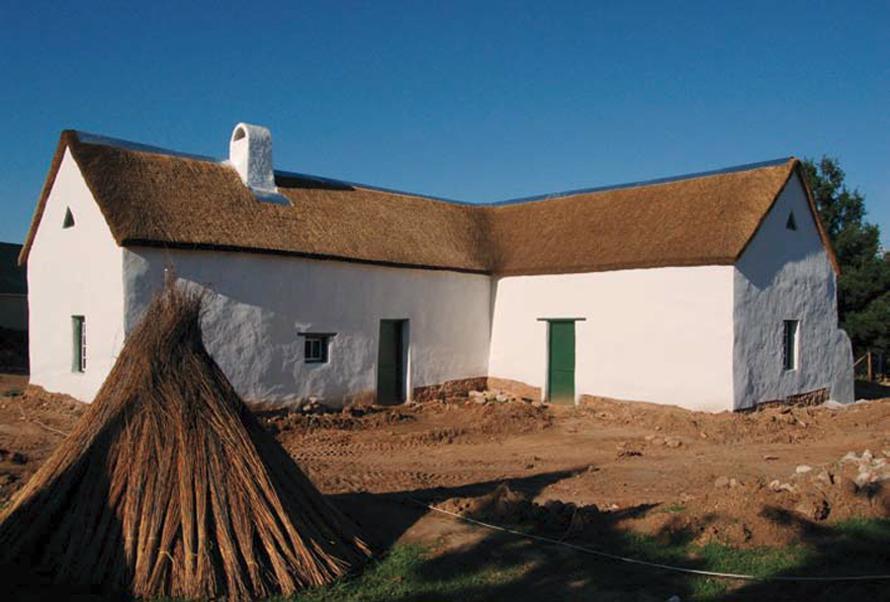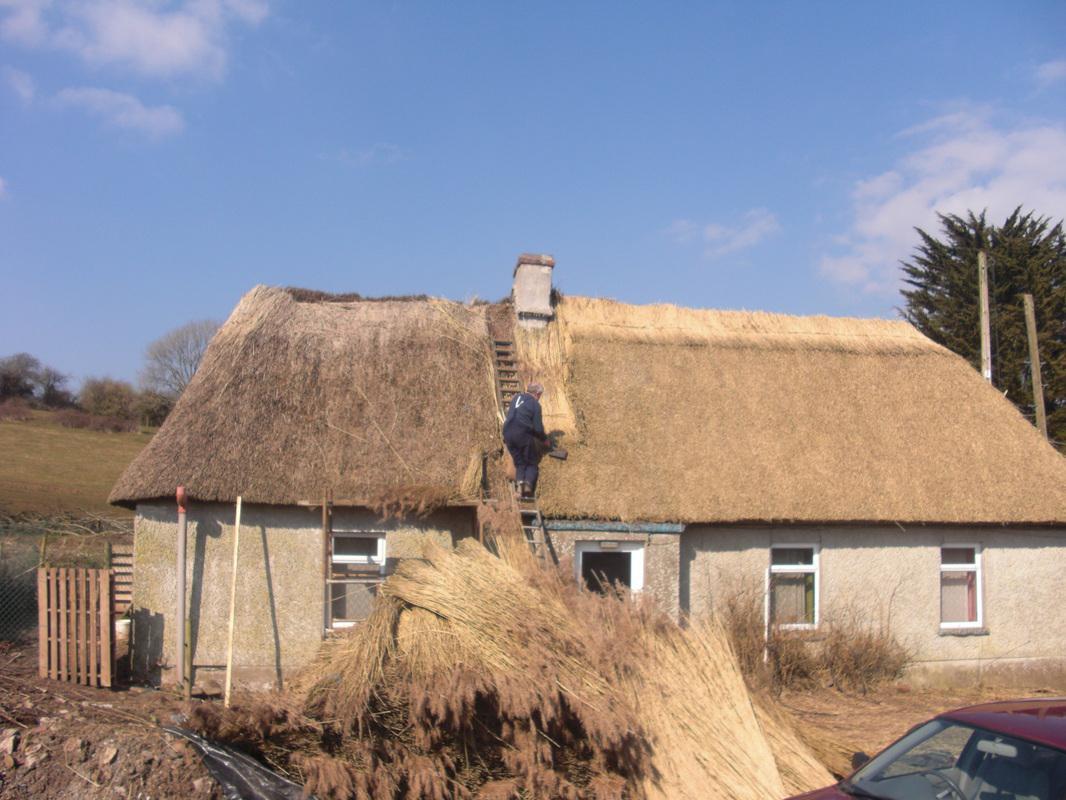The first image is the image on the left, the second image is the image on the right. Examine the images to the left and right. Is the description "In the left image, the roof is currently being thatched; the thatching has started, but has not completed." accurate? Answer yes or no. No. The first image is the image on the left, the second image is the image on the right. For the images displayed, is the sentence "In one image, thatch is piled in a heap in front of a non-brick buildling being re-thatched, with new thatch on the right side of the roof." factually correct? Answer yes or no. Yes. 